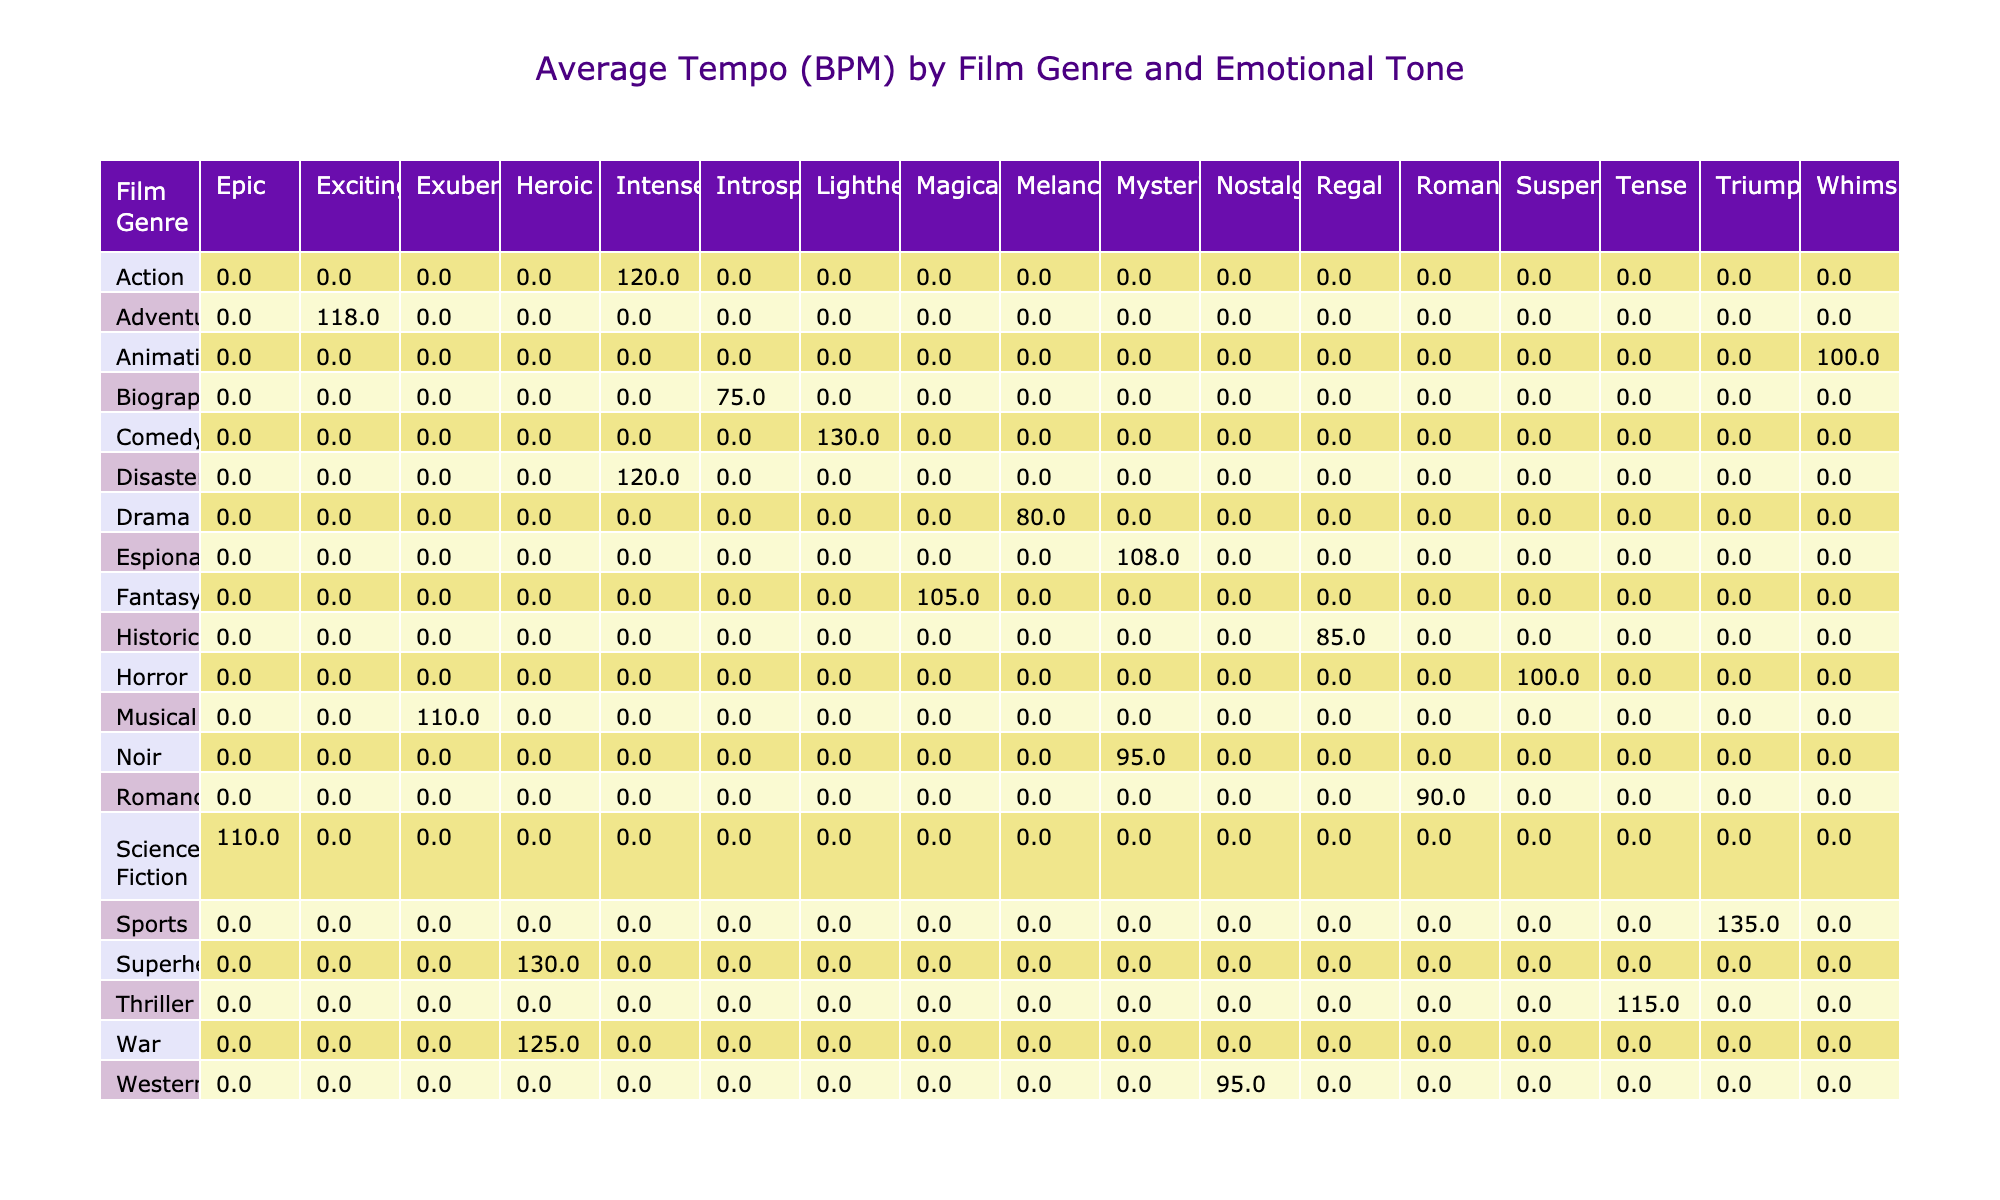What is the average tempo of action films? The table shows the average tempo for various genres categorized by emotional tone. For action films, the tempo is listed under the "Intense" emotional tone, which is 120 BPM.
Answer: 120 BPM Which film genre has the highest average tempo? By examining the average tempos for all genres, the highest value is 135 BPM found in the Sports genre.
Answer: Sports, 135 BPM Do all genres represented have a high use of leitmotifs? The table indicates that not all genres have a high rate of leitmotif usage. For instance, Comedy and Horror exhibit a low utilization of leitmotifs.
Answer: No What is the average tempo for drama films compared to horror films? The average tempo for Drama films is 80 BPM, while Horror films have an average tempo of 100 BPM. Thus, Horror films have a higher average tempo by 20 BPM.
Answer: 20 BPM Which genre has the highest orchestration complexity among those that have won at least one award? Among the genres that have won awards, Fantasy has the highest orchestration complexity, listed as "Very Complex". It also has achieved four awards.
Answer: Fantasy How many genres have an emotional tone of "Heroic"? The genres with an emotional tone of "Heroic" are Action and Superhero. Therefore, a total of two genres possess this emotional tone.
Answer: 2 What is the difference in average tempo between action films and adventure films? The average tempo for action films is 120 BPM, while the tempo for adventure films is 118 BPM. The difference in average tempo is 2 BPM, with action films being slightly faster.
Answer: 2 BPM Which genres have a melancholic emotional tone? According to the table, the only genre that has a melancholic emotional tone is Drama, which has an average tempo of 80 BPM.
Answer: Drama Are there any genres from the 2000s that won no awards? The genres from the 2000s that did not win any awards are War (2005) and Espionage (2006). Therefore, both genres fit the criteria of being from that decade and having no awards.
Answer: Yes 